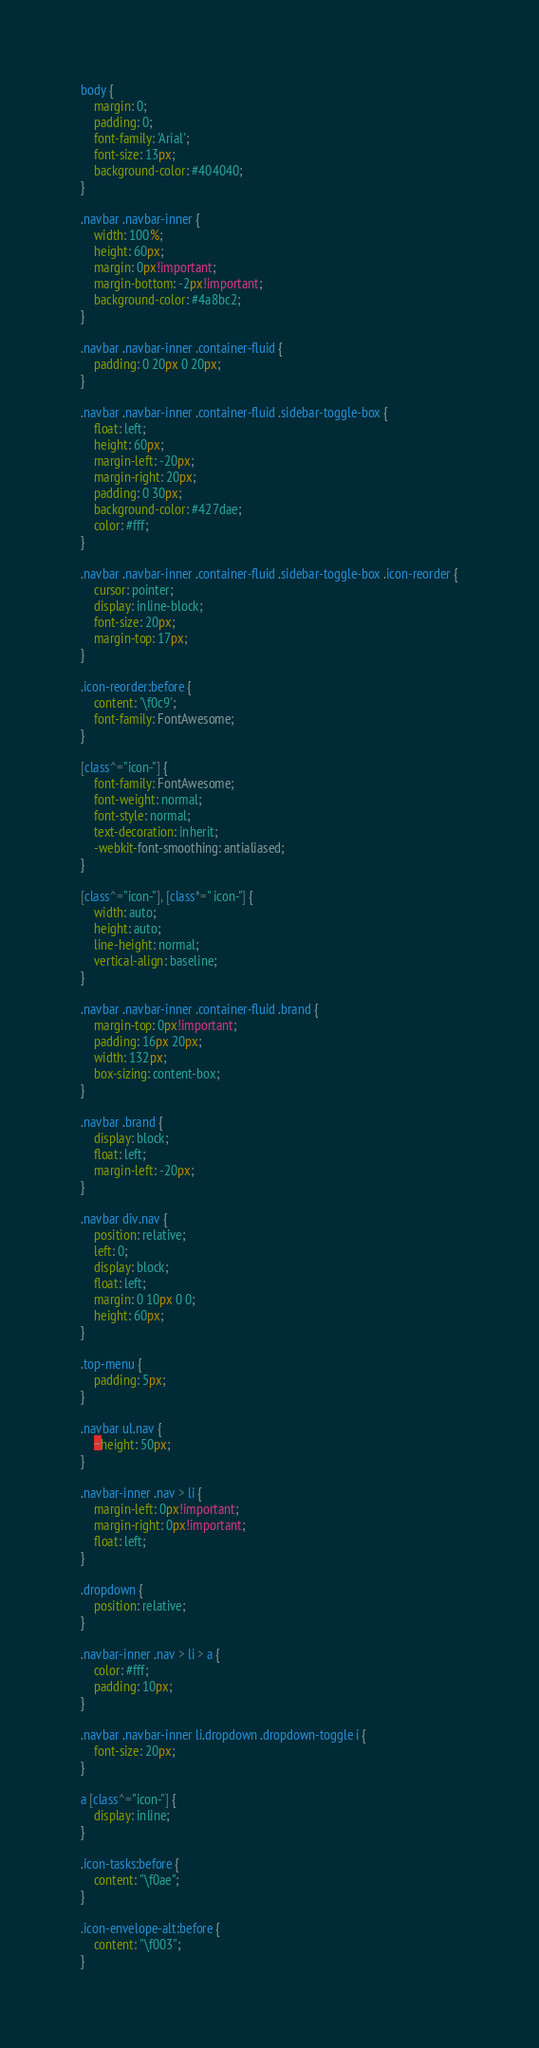<code> <loc_0><loc_0><loc_500><loc_500><_CSS_>body {
	margin: 0;
	padding: 0;
	font-family: 'Arial';
	font-size: 13px;
	background-color: #404040;
}

.navbar .navbar-inner {
	width: 100%;
	height: 60px;
	margin: 0px!important;
	margin-bottom: -2px!important;
	background-color: #4a8bc2;
}

.navbar .navbar-inner .container-fluid {
	padding: 0 20px 0 20px;
}

.navbar .navbar-inner .container-fluid .sidebar-toggle-box {
	float: left;
	height: 60px;
	margin-left: -20px;
	margin-right: 20px;
	padding: 0 30px;
	background-color: #427dae;
	color: #fff;
}

.navbar .navbar-inner .container-fluid .sidebar-toggle-box .icon-reorder {
	cursor: pointer;
	display: inline-block;
	font-size: 20px;
	margin-top: 17px;
}

.icon-reorder:before {
	content: '\f0c9';
	font-family: FontAwesome;
}

[class^="icon-"] {
	font-family: FontAwesome;
    font-weight: normal;
    font-style: normal;
    text-decoration: inherit;
    -webkit-font-smoothing: antialiased;
}

[class^="icon-"], [class*=" icon-"] {
	width: auto;
	height: auto;
	line-height: normal;
	vertical-align: baseline;
}

.navbar .navbar-inner .container-fluid .brand {
	margin-top: 0px!important;
	padding: 16px 20px;
	width: 132px;
	box-sizing: content-box;
}

.navbar .brand {
	display: block;
	float: left;
	margin-left: -20px;
}

.navbar div.nav {
	position: relative;
	left: 0;
	display: block;
	float: left;
	margin: 0 10px 0 0;
	height: 60px;
}

.top-menu {
	padding: 5px;
}

.navbar ul.nav {
	~height: 50px;
}

.navbar-inner .nav > li {
	margin-left: 0px!important;
	margin-right: 0px!important;
	float: left;
}

.dropdown {
	position: relative;
}

.navbar-inner .nav > li > a {
	color: #fff;
	padding: 10px;
}

.navbar .navbar-inner li.dropdown .dropdown-toggle i {
	font-size: 20px;
}

a [class^="icon-"] {
    display: inline;
}

.icon-tasks:before {
	content: "\f0ae";
}

.icon-envelope-alt:before {
	content: "\f003";
}
</code> 